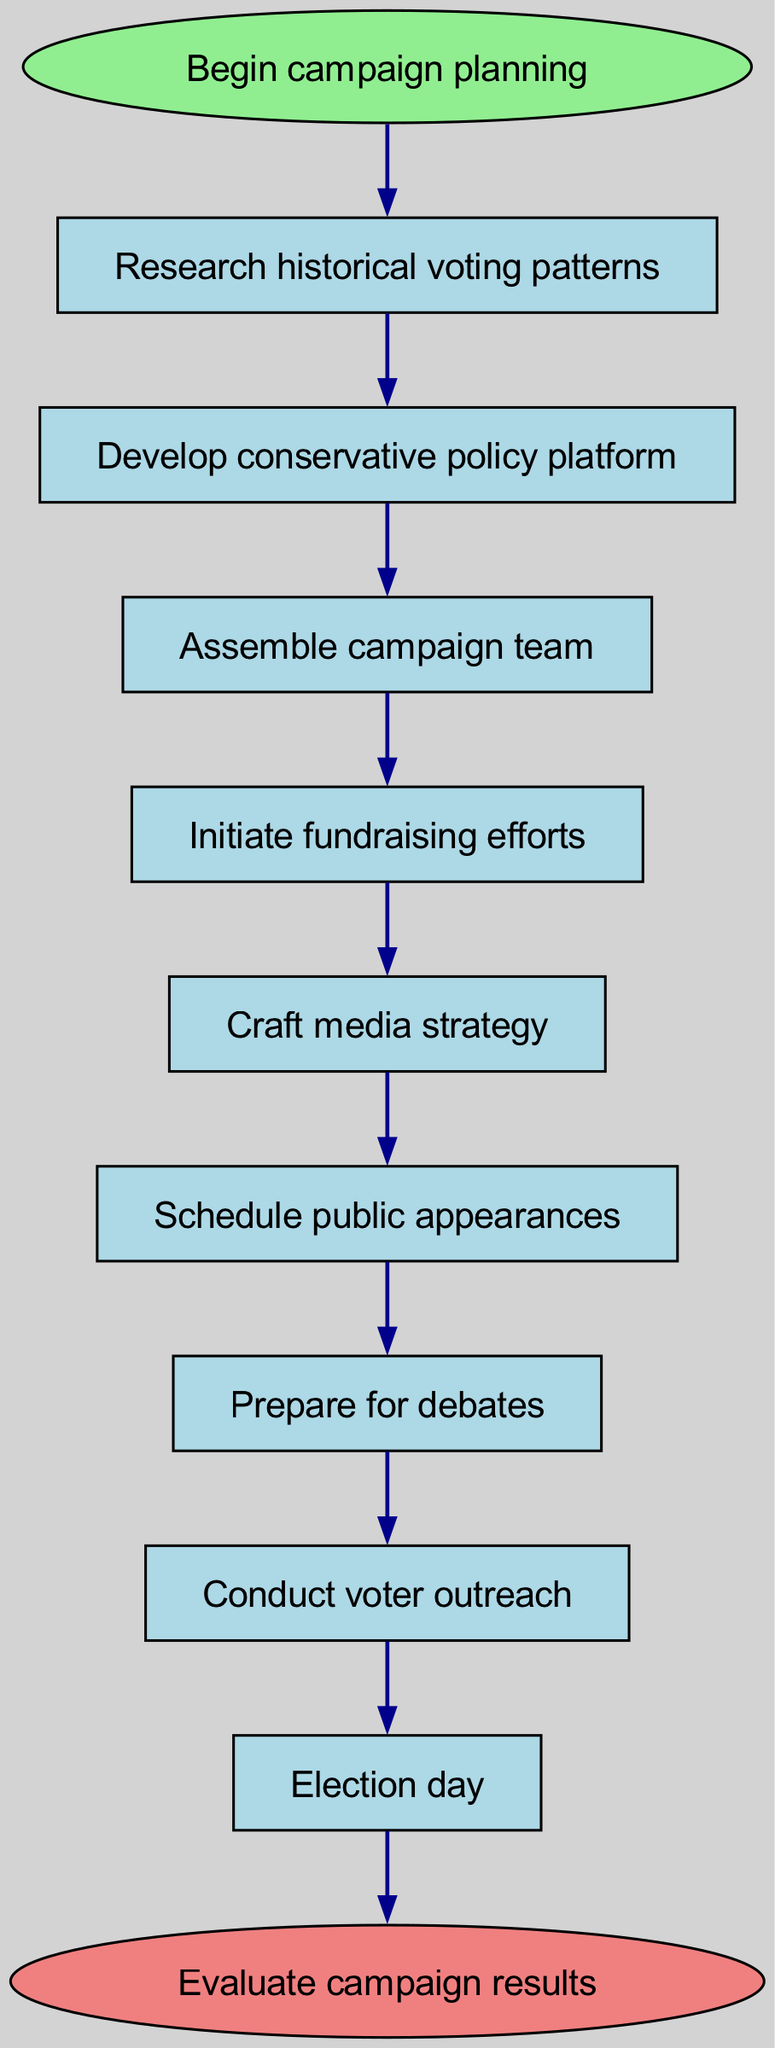What is the first step in the campaign planning process? The diagram starts with the node labeled "Begin campaign planning," indicating this is the first action to take.
Answer: Begin campaign planning How many elements are there in the flow chart? There are ten nodes in total as listed in the provided data, representing different steps in the campaign process.
Answer: Ten What is the last step before election day? The diagram shows that "Conduct voter outreach" occurs immediately before "Election day," making it the last step before that crucial event.
Answer: Conduct voter outreach Which step follows after developing a conservative policy platform? According to the flowchart, after "Develop conservative policy platform," the next step is "Assemble campaign team." This connection is direct and sequential.
Answer: Assemble campaign team What indicates the end of the campaign process? The flow chart concludes with the node labeled "Evaluate campaign results," which signifies the final step in the campaign process.
Answer: Evaluate campaign results How many actions are there between fundraising and public appearances? There is only one action listed in the chart between "Initiate fundraising efforts" and "Schedule public appearances," which is "Craft media strategy."
Answer: One What step comes immediately after preparing for debates? The direct connection in the flow chart shows that "Conduct voter outreach" follows immediately after "Prepare for debates."
Answer: Conduct voter outreach What is the relationship between the research node and the platform node? The diagram illustrates a direct sequential connection from "Research historical voting patterns" to "Develop conservative policy platform," indicating that research informs the platform.
Answer: Direct sequential connection What color represents the start and end nodes? The start node is represented in light green, while the end node displays light coral, which visually differentiates the initiation and completion steps.
Answer: Light green and light coral 